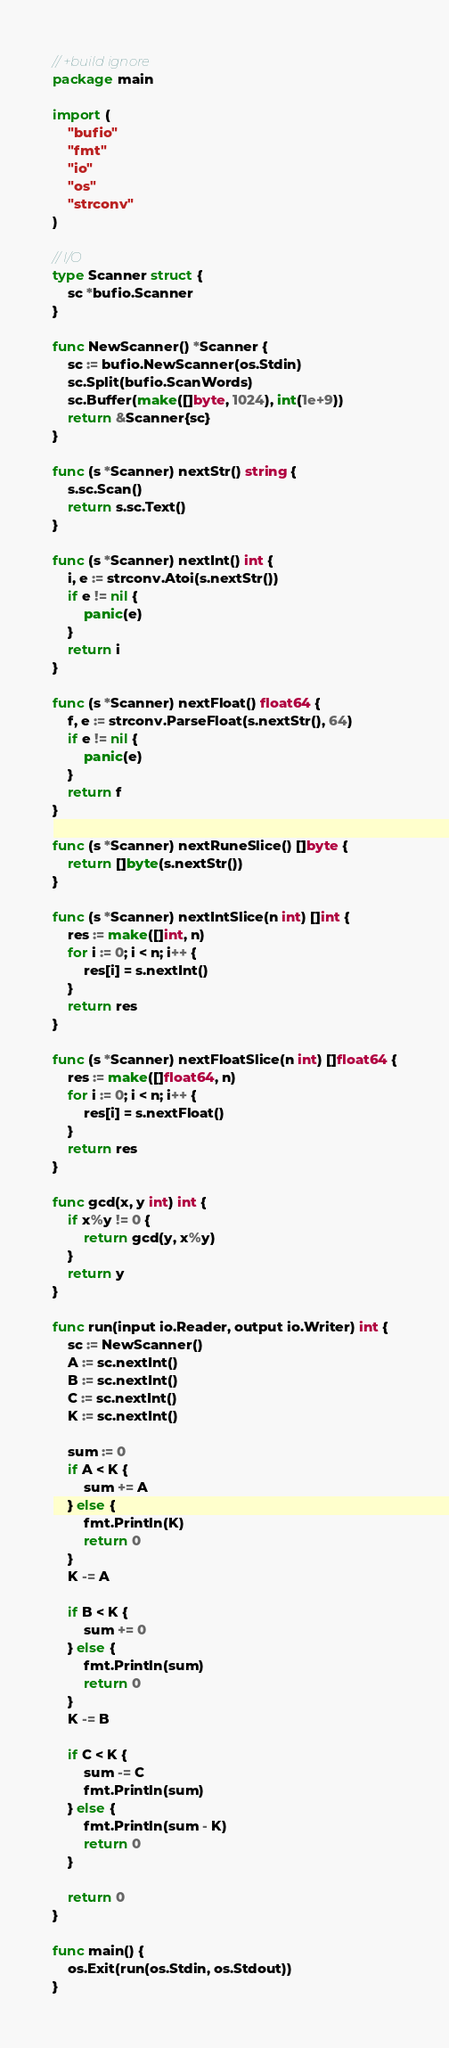<code> <loc_0><loc_0><loc_500><loc_500><_Go_>// +build ignore
package main

import (
	"bufio"
	"fmt"
	"io"
	"os"
	"strconv"
)

// I/O
type Scanner struct {
	sc *bufio.Scanner
}

func NewScanner() *Scanner {
	sc := bufio.NewScanner(os.Stdin)
	sc.Split(bufio.ScanWords)
	sc.Buffer(make([]byte, 1024), int(1e+9))
	return &Scanner{sc}
}

func (s *Scanner) nextStr() string {
	s.sc.Scan()
	return s.sc.Text()
}

func (s *Scanner) nextInt() int {
	i, e := strconv.Atoi(s.nextStr())
	if e != nil {
		panic(e)
	}
	return i
}

func (s *Scanner) nextFloat() float64 {
	f, e := strconv.ParseFloat(s.nextStr(), 64)
	if e != nil {
		panic(e)
	}
	return f
}

func (s *Scanner) nextRuneSlice() []byte {
	return []byte(s.nextStr())
}

func (s *Scanner) nextIntSlice(n int) []int {
	res := make([]int, n)
	for i := 0; i < n; i++ {
		res[i] = s.nextInt()
	}
	return res
}

func (s *Scanner) nextFloatSlice(n int) []float64 {
	res := make([]float64, n)
	for i := 0; i < n; i++ {
		res[i] = s.nextFloat()
	}
	return res
}

func gcd(x, y int) int {
	if x%y != 0 {
		return gcd(y, x%y)
	}
	return y
}

func run(input io.Reader, output io.Writer) int {
	sc := NewScanner()
	A := sc.nextInt()
	B := sc.nextInt()
	C := sc.nextInt()
	K := sc.nextInt()

	sum := 0
	if A < K {
		sum += A
	} else {
		fmt.Println(K)
		return 0
	}
	K -= A

	if B < K {
		sum += 0
	} else {
		fmt.Println(sum)
		return 0
	}
	K -= B

	if C < K {
		sum -= C
		fmt.Println(sum)
	} else {
		fmt.Println(sum - K)
		return 0
	}

	return 0
}

func main() {
	os.Exit(run(os.Stdin, os.Stdout))
}
</code> 